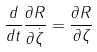Convert formula to latex. <formula><loc_0><loc_0><loc_500><loc_500>\frac { d } { d t } \frac { \partial R } { \partial \dot { \zeta } } = \frac { \partial R } { \partial \zeta }</formula> 